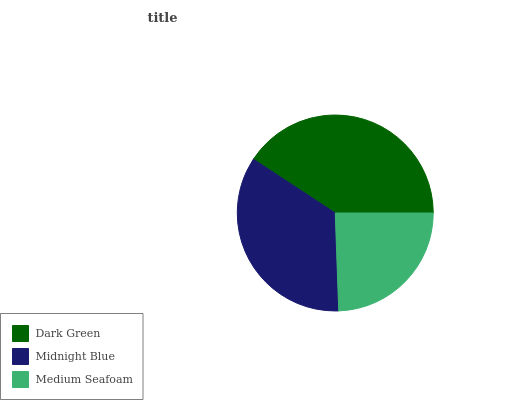Is Medium Seafoam the minimum?
Answer yes or no. Yes. Is Dark Green the maximum?
Answer yes or no. Yes. Is Midnight Blue the minimum?
Answer yes or no. No. Is Midnight Blue the maximum?
Answer yes or no. No. Is Dark Green greater than Midnight Blue?
Answer yes or no. Yes. Is Midnight Blue less than Dark Green?
Answer yes or no. Yes. Is Midnight Blue greater than Dark Green?
Answer yes or no. No. Is Dark Green less than Midnight Blue?
Answer yes or no. No. Is Midnight Blue the high median?
Answer yes or no. Yes. Is Midnight Blue the low median?
Answer yes or no. Yes. Is Medium Seafoam the high median?
Answer yes or no. No. Is Medium Seafoam the low median?
Answer yes or no. No. 